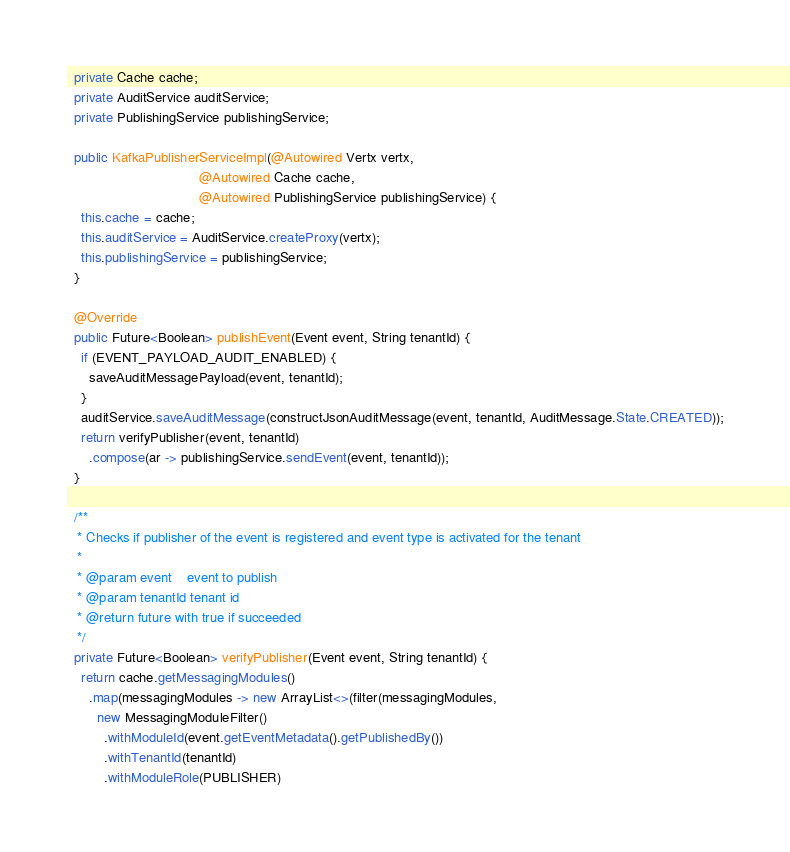Convert code to text. <code><loc_0><loc_0><loc_500><loc_500><_Java_>
  private Cache cache;
  private AuditService auditService;
  private PublishingService publishingService;

  public KafkaPublisherServiceImpl(@Autowired Vertx vertx,
                                   @Autowired Cache cache,
                                   @Autowired PublishingService publishingService) {
    this.cache = cache;
    this.auditService = AuditService.createProxy(vertx);
    this.publishingService = publishingService;
  }

  @Override
  public Future<Boolean> publishEvent(Event event, String tenantId) {
    if (EVENT_PAYLOAD_AUDIT_ENABLED) {
      saveAuditMessagePayload(event, tenantId);
    }
    auditService.saveAuditMessage(constructJsonAuditMessage(event, tenantId, AuditMessage.State.CREATED));
    return verifyPublisher(event, tenantId)
      .compose(ar -> publishingService.sendEvent(event, tenantId));
  }

  /**
   * Checks if publisher of the event is registered and event type is activated for the tenant
   *
   * @param event    event to publish
   * @param tenantId tenant id
   * @return future with true if succeeded
   */
  private Future<Boolean> verifyPublisher(Event event, String tenantId) {
    return cache.getMessagingModules()
      .map(messagingModules -> new ArrayList<>(filter(messagingModules,
        new MessagingModuleFilter()
          .withModuleId(event.getEventMetadata().getPublishedBy())
          .withTenantId(tenantId)
          .withModuleRole(PUBLISHER)</code> 